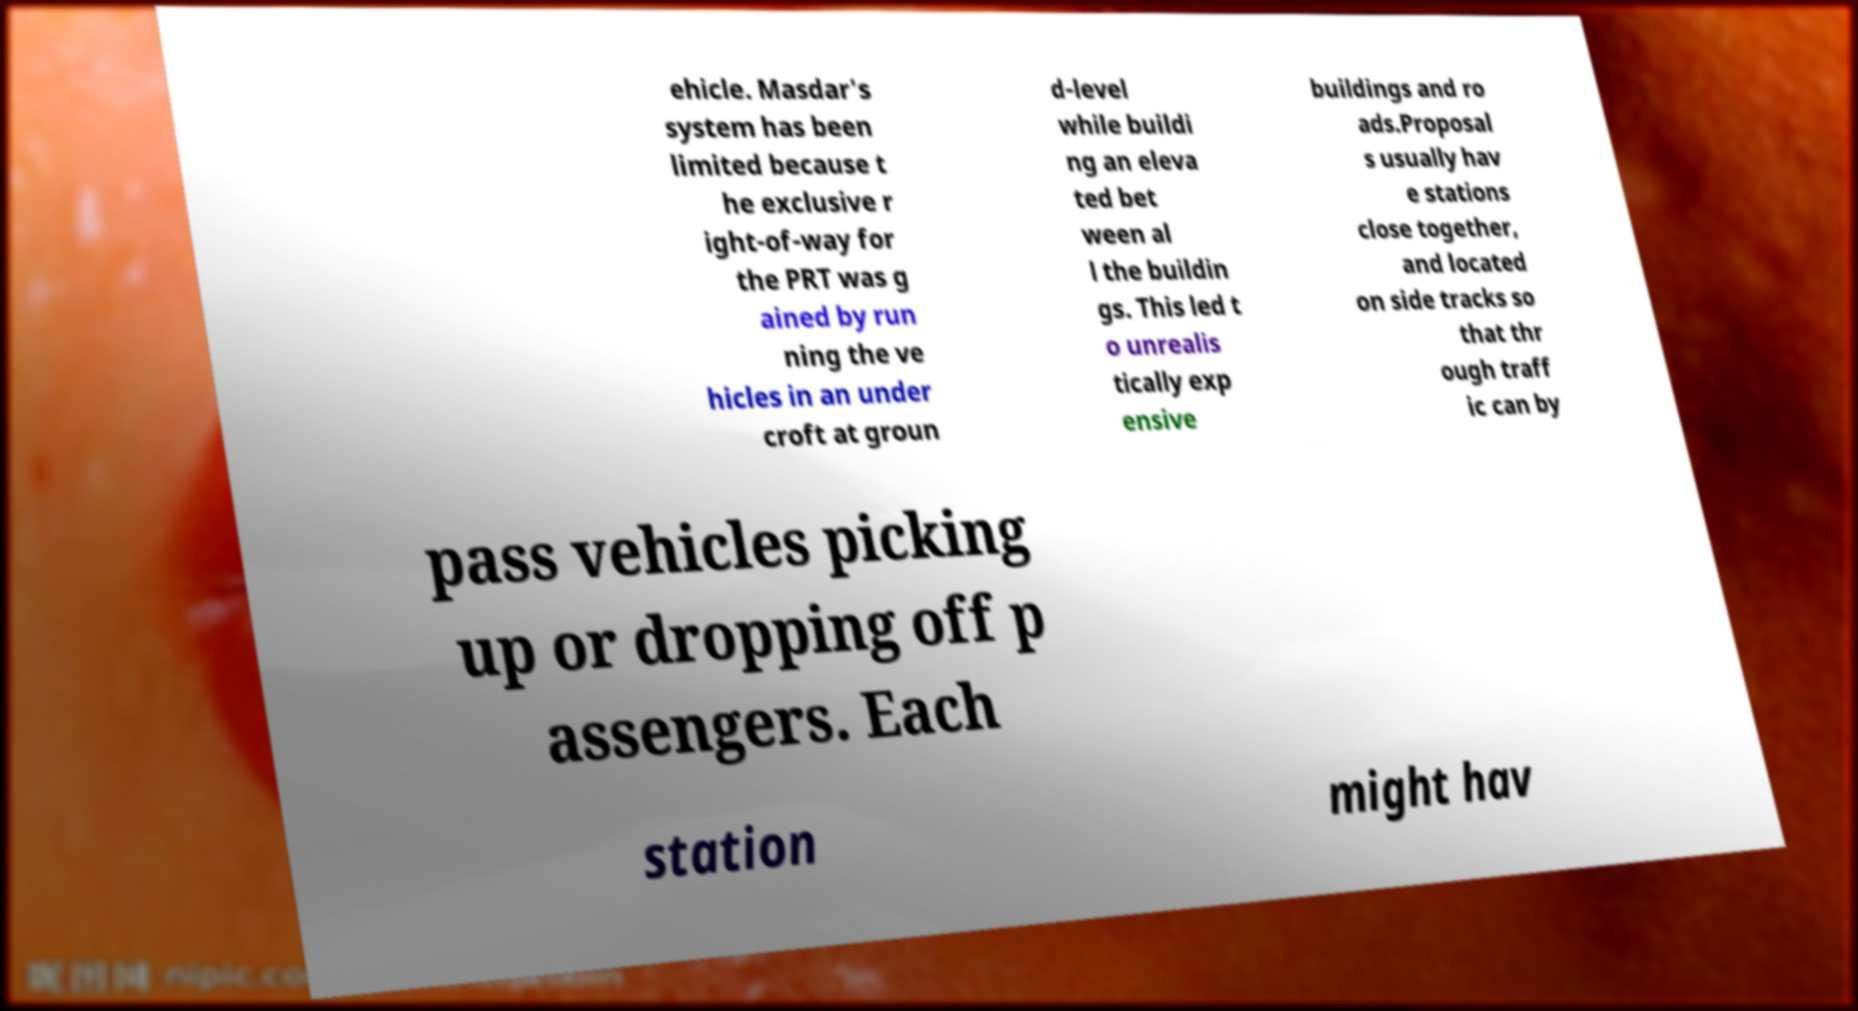For documentation purposes, I need the text within this image transcribed. Could you provide that? ehicle. Masdar's system has been limited because t he exclusive r ight-of-way for the PRT was g ained by run ning the ve hicles in an under croft at groun d-level while buildi ng an eleva ted bet ween al l the buildin gs. This led t o unrealis tically exp ensive buildings and ro ads.Proposal s usually hav e stations close together, and located on side tracks so that thr ough traff ic can by pass vehicles picking up or dropping off p assengers. Each station might hav 